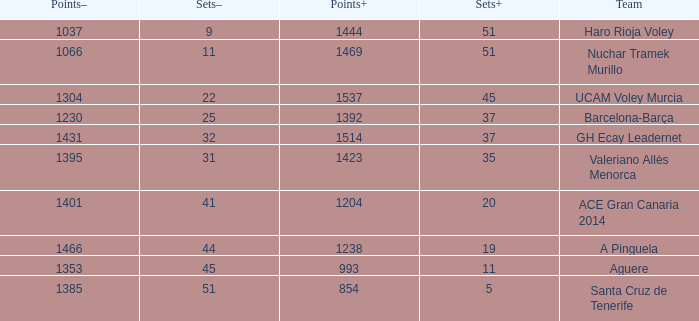Who is the team who had a Sets+ number smaller than 20, a Sets- number of 45, and a Points+ number smaller than 1238? Aguere. 